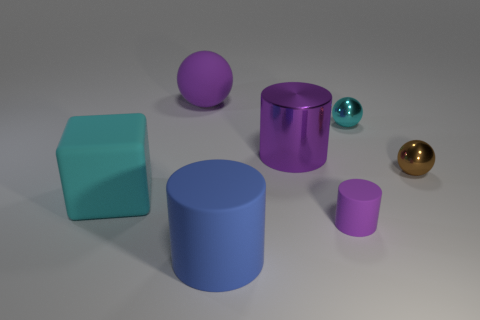There is a shiny ball that is the same color as the block; what size is it?
Provide a succinct answer. Small. What shape is the other large thing that is the same color as the big shiny object?
Offer a terse response. Sphere. What number of objects are both on the left side of the tiny brown metal object and behind the big cyan object?
Keep it short and to the point. 3. Is there a cube that is in front of the metal object that is on the left side of the purple matte thing in front of the purple shiny cylinder?
Provide a short and direct response. Yes. What is the shape of the metallic thing that is the same size as the brown ball?
Ensure brevity in your answer.  Sphere. Are there any small spheres that have the same color as the big metallic cylinder?
Your response must be concise. No. Does the large blue matte thing have the same shape as the small matte thing?
Offer a very short reply. Yes. What number of large objects are gray blocks or purple things?
Provide a succinct answer. 2. What is the color of the tiny object that is made of the same material as the large cyan cube?
Keep it short and to the point. Purple. What number of big objects are the same material as the brown sphere?
Ensure brevity in your answer.  1. 